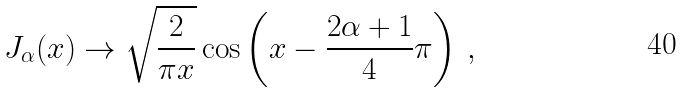Convert formula to latex. <formula><loc_0><loc_0><loc_500><loc_500>J _ { \alpha } ( x ) \to \sqrt { \frac { 2 } { \pi x } } \cos \left ( x - \frac { 2 \alpha + 1 } { 4 } \pi \right ) \, ,</formula> 